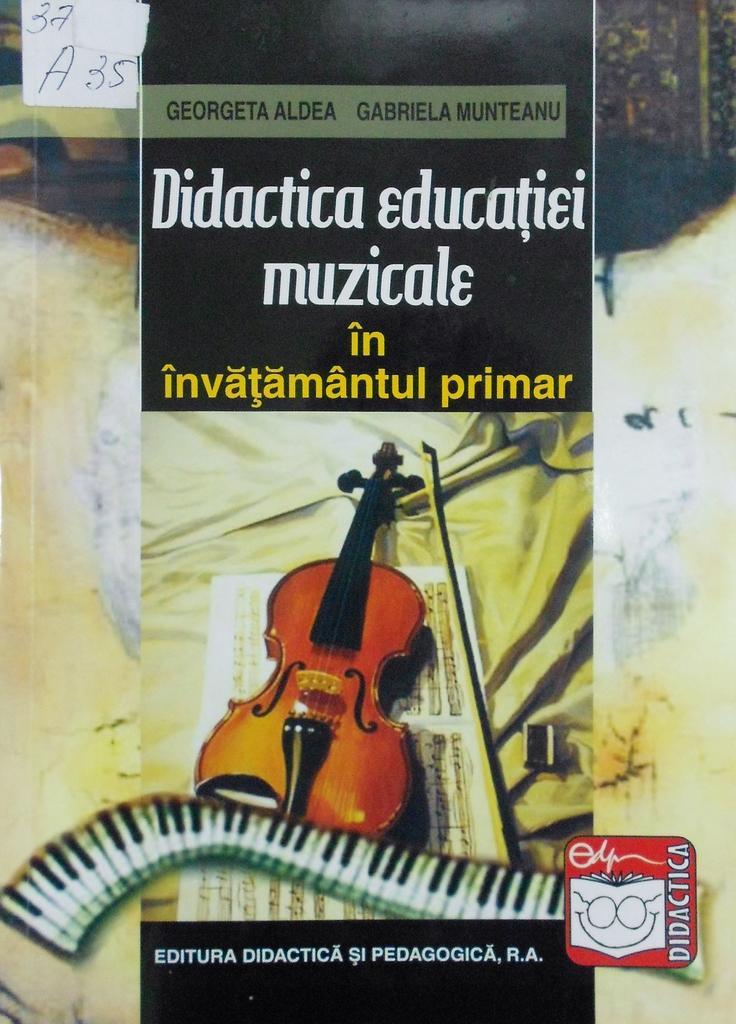Can you describe this image briefly? In this image, we can see a poster, on that poster we can see a guitar picture and there is some text on the poster. 